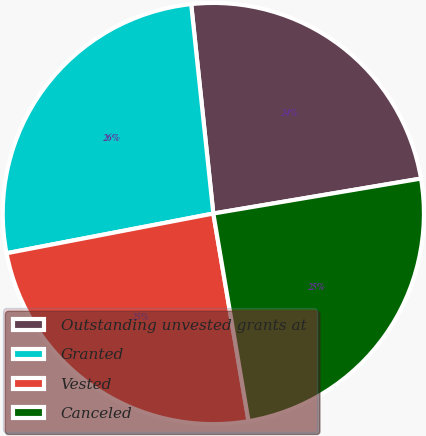<chart> <loc_0><loc_0><loc_500><loc_500><pie_chart><fcel>Outstanding unvested grants at<fcel>Granted<fcel>Vested<fcel>Canceled<nl><fcel>24.02%<fcel>26.34%<fcel>24.65%<fcel>24.98%<nl></chart> 